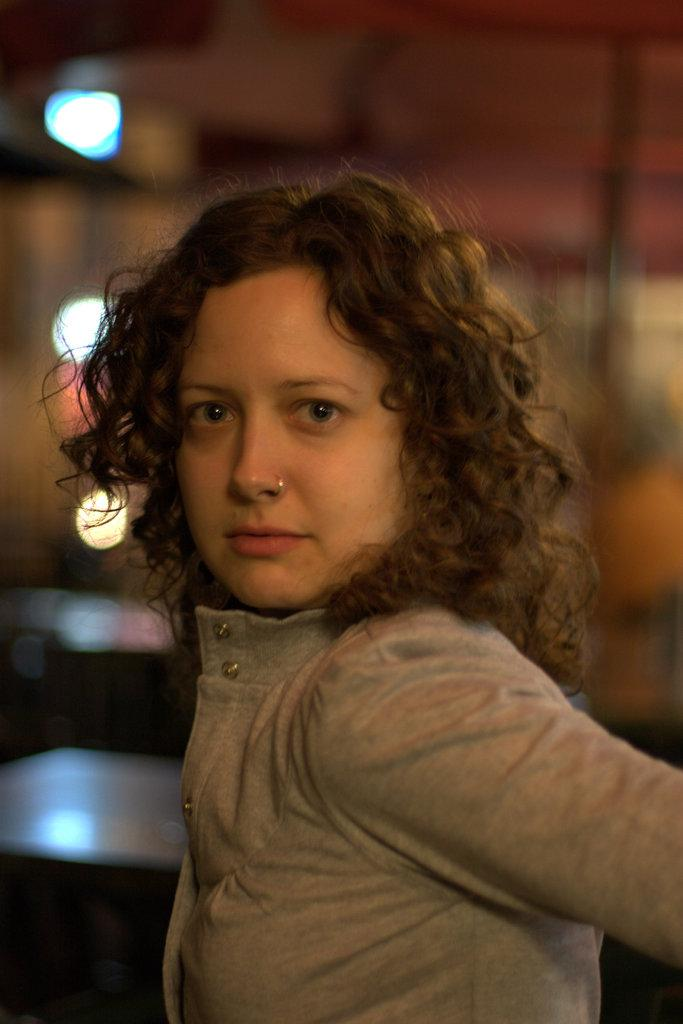Who is the main subject in the foreground of the image? There is a woman in the foreground of the image. What can be observed about the background of the image? The background of the image is blurry. What can be seen in the background of the image? There are lights visible in the background of the image. Are there any other objects present in the background of the image? Yes, there are other objects present in the background of the image. What type of spark can be seen coming from the hammer in the image? There is no hammer present in the image, so it is not possible to determine if there is a spark coming from it. 